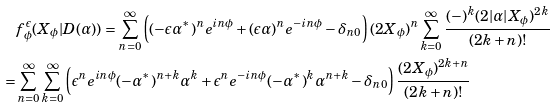<formula> <loc_0><loc_0><loc_500><loc_500>& f _ { \phi } ^ { \epsilon } ( X _ { \phi } | D ( \alpha ) ) = \sum _ { n = 0 } ^ { \infty } \left ( ( - \epsilon \alpha ^ { * } ) ^ { n } e ^ { i n \phi } + ( \epsilon \alpha ) ^ { n } e ^ { - i n \phi } - \delta _ { n 0 } \right ) ( 2 X _ { \phi } ) ^ { n } \sum _ { k = 0 } ^ { \infty } \frac { ( - ) ^ { k } ( 2 | \alpha | X _ { \phi } ) ^ { 2 k } } { ( 2 k + n ) ! } \\ = & \sum _ { n = 0 } ^ { \infty } \sum _ { k = 0 } ^ { \infty } \left ( \epsilon ^ { n } e ^ { i n \phi } ( - \alpha ^ { * } ) ^ { n + k } \alpha ^ { k } + \epsilon ^ { n } e ^ { - i n \phi } ( - \alpha ^ { * } ) ^ { k } \alpha ^ { n + k } - \delta _ { n 0 } \right ) \frac { ( 2 X _ { \phi } ) ^ { 2 k + n } } { ( 2 k + n ) ! }</formula> 